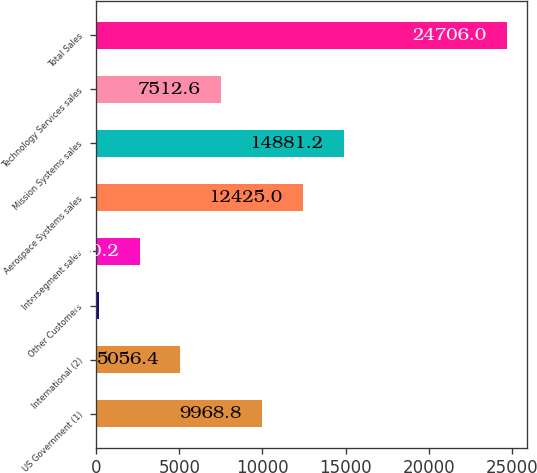Convert chart to OTSL. <chart><loc_0><loc_0><loc_500><loc_500><bar_chart><fcel>US Government (1)<fcel>International (2)<fcel>Other Customers<fcel>Intersegment sales<fcel>Aerospace Systems sales<fcel>Mission Systems sales<fcel>Technology Services sales<fcel>Total Sales<nl><fcel>9968.8<fcel>5056.4<fcel>144<fcel>2600.2<fcel>12425<fcel>14881.2<fcel>7512.6<fcel>24706<nl></chart> 